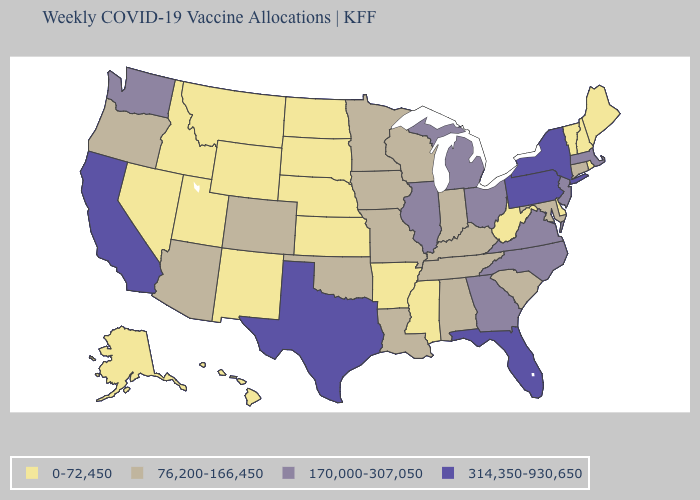What is the lowest value in the MidWest?
Be succinct. 0-72,450. Does Maryland have the lowest value in the USA?
Keep it brief. No. Does the first symbol in the legend represent the smallest category?
Answer briefly. Yes. How many symbols are there in the legend?
Give a very brief answer. 4. What is the value of Idaho?
Quick response, please. 0-72,450. Does Oklahoma have the lowest value in the USA?
Short answer required. No. Among the states that border Vermont , which have the highest value?
Write a very short answer. New York. Name the states that have a value in the range 0-72,450?
Write a very short answer. Alaska, Arkansas, Delaware, Hawaii, Idaho, Kansas, Maine, Mississippi, Montana, Nebraska, Nevada, New Hampshire, New Mexico, North Dakota, Rhode Island, South Dakota, Utah, Vermont, West Virginia, Wyoming. Does Illinois have a higher value than Florida?
Give a very brief answer. No. Among the states that border Georgia , does Tennessee have the lowest value?
Be succinct. Yes. Name the states that have a value in the range 76,200-166,450?
Keep it brief. Alabama, Arizona, Colorado, Connecticut, Indiana, Iowa, Kentucky, Louisiana, Maryland, Minnesota, Missouri, Oklahoma, Oregon, South Carolina, Tennessee, Wisconsin. Does Missouri have a higher value than Wisconsin?
Give a very brief answer. No. What is the value of Minnesota?
Give a very brief answer. 76,200-166,450. Does Rhode Island have the lowest value in the Northeast?
Write a very short answer. Yes. What is the value of Arkansas?
Quick response, please. 0-72,450. 